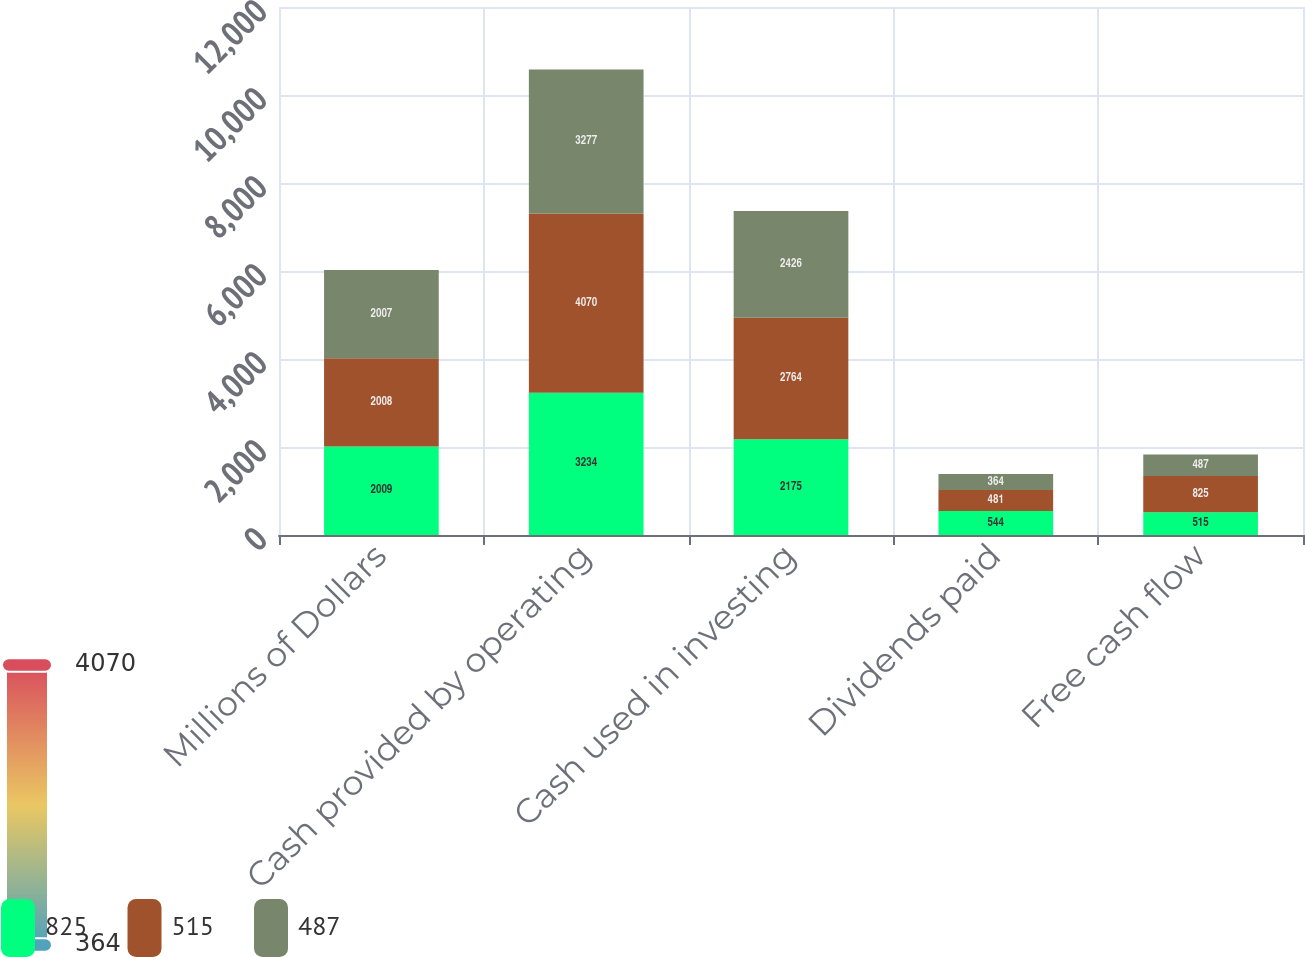Convert chart. <chart><loc_0><loc_0><loc_500><loc_500><stacked_bar_chart><ecel><fcel>Millions of Dollars<fcel>Cash provided by operating<fcel>Cash used in investing<fcel>Dividends paid<fcel>Free cash flow<nl><fcel>825<fcel>2009<fcel>3234<fcel>2175<fcel>544<fcel>515<nl><fcel>515<fcel>2008<fcel>4070<fcel>2764<fcel>481<fcel>825<nl><fcel>487<fcel>2007<fcel>3277<fcel>2426<fcel>364<fcel>487<nl></chart> 